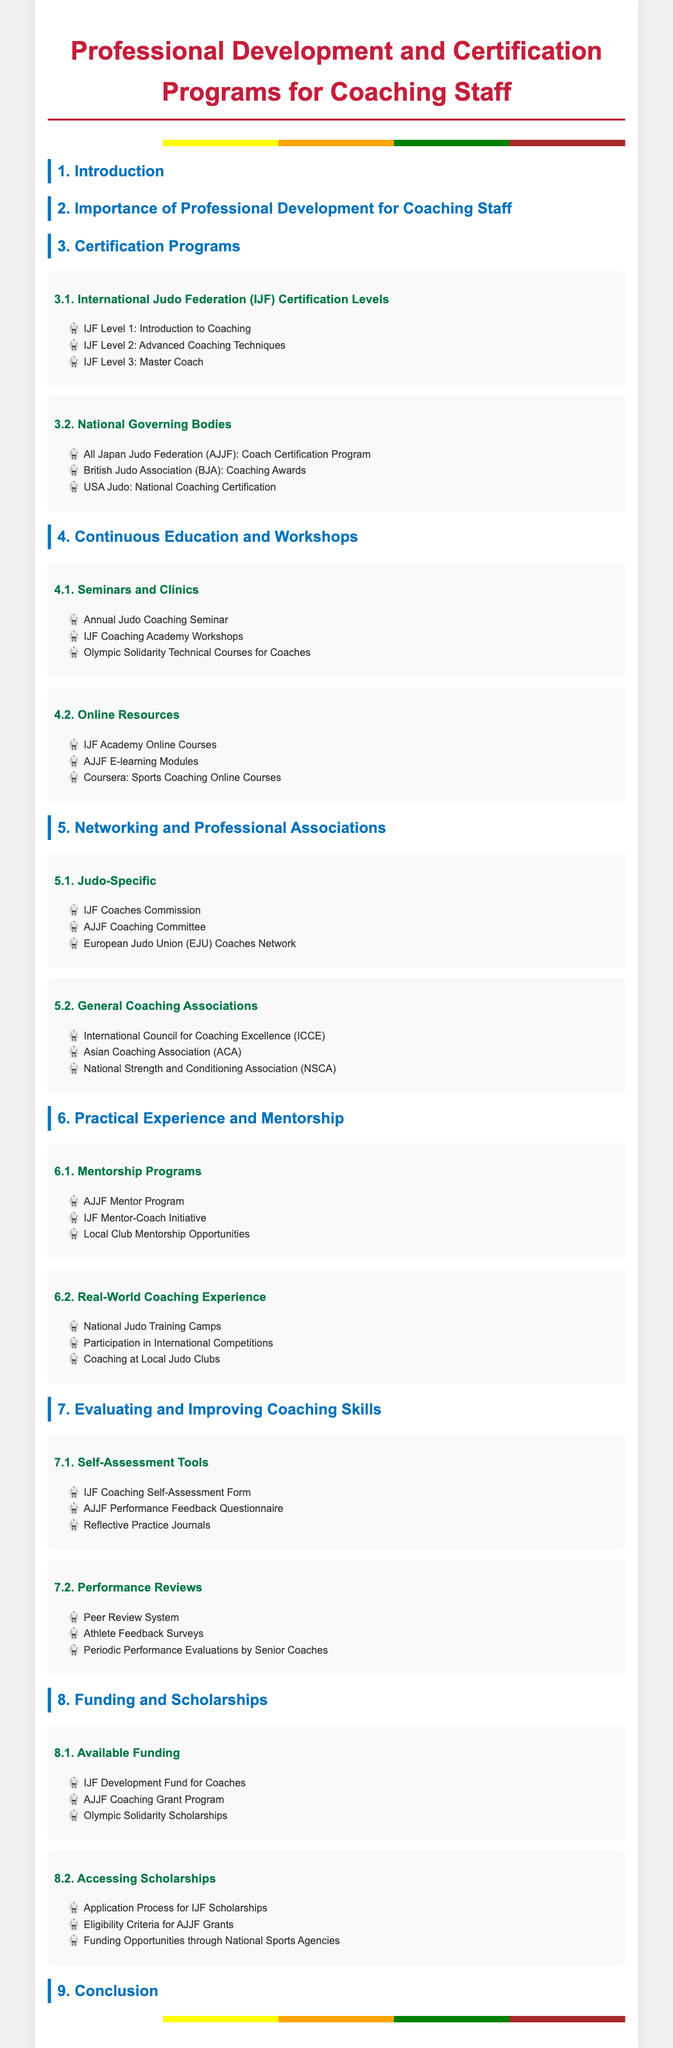What is the highest certification level offered by IJF? The document mentions three certification levels, with the highest being IJF Level 3.
Answer: IJF Level 3 What are the three types of certification programs listed under National Governing Bodies? The document lists three different organizations with their respective certification programs.
Answer: AJJF, BJA, USA Judo How many types of online resources are mentioned? The document categorizes online resources into three specific types related to coaching.
Answer: 3 What is one of the mentorship programs listed for coaches? The document provides examples of mentorship programs implemented for coaching staff.
Answer: AJJF Mentor Program Which association is named specifically for judo in the networking section? The document lists several organizations, specifically mentioning the IJF Coaches Commission as a judo-specific association.
Answer: IJF Coaches Commission What feedback tool is used for self-assessment? The document describes self-assessment tools available for coaching staff, including one specific form mentioned.
Answer: IJF Coaching Self-Assessment Form How many scholarships or funding opportunities are discussed in the document? The document references various funding opportunities, categorizing them into two main types.
Answer: 3 What type of courses does the IJF Academy offer? The document specifies the nature of the online courses provided by the IJF Academy.
Answer: Online Courses What event is mentioned as part of continuous education for coaches? The document lists events aimed at the continuous education of coaching staff.
Answer: Annual Judo Coaching Seminar 